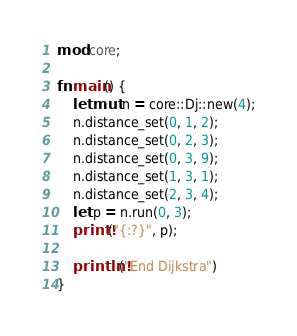Convert code to text. <code><loc_0><loc_0><loc_500><loc_500><_Rust_>mod core;

fn main() {
    let mut n = core::Dj::new(4);
    n.distance_set(0, 1, 2);
    n.distance_set(0, 2, 3);
    n.distance_set(0, 3, 9);
    n.distance_set(1, 3, 1);
    n.distance_set(2, 3, 4);
    let p = n.run(0, 3);
    print!("{:?}", p);

    println!("End Dijkstra")
}
</code> 